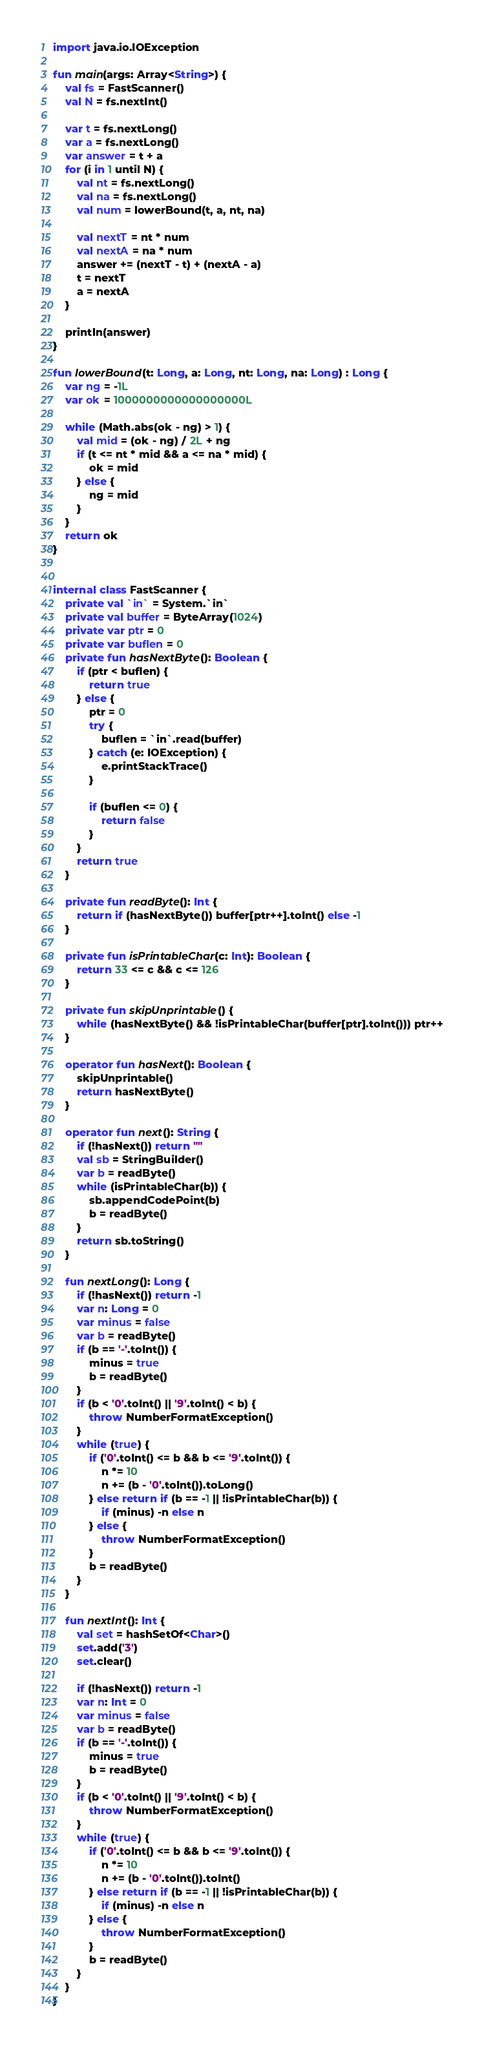Convert code to text. <code><loc_0><loc_0><loc_500><loc_500><_Kotlin_>import java.io.IOException

fun main(args: Array<String>) {
    val fs = FastScanner()
    val N = fs.nextInt()

    var t = fs.nextLong()
    var a = fs.nextLong()
    var answer = t + a
    for (i in 1 until N) {
        val nt = fs.nextLong()
        val na = fs.nextLong()
        val num = lowerBound(t, a, nt, na)

        val nextT = nt * num
        val nextA = na * num
        answer += (nextT - t) + (nextA - a)
        t = nextT
        a = nextA
    }

    println(answer)
}

fun lowerBound(t: Long, a: Long, nt: Long, na: Long) : Long {
    var ng = -1L
    var ok = 1000000000000000000L

    while (Math.abs(ok - ng) > 1) {
        val mid = (ok - ng) / 2L + ng
        if (t <= nt * mid && a <= na * mid) {
            ok = mid
        } else {
            ng = mid
        }
    }
    return ok
}


internal class FastScanner {
    private val `in` = System.`in`
    private val buffer = ByteArray(1024)
    private var ptr = 0
    private var buflen = 0
    private fun hasNextByte(): Boolean {
        if (ptr < buflen) {
            return true
        } else {
            ptr = 0
            try {
                buflen = `in`.read(buffer)
            } catch (e: IOException) {
                e.printStackTrace()
            }

            if (buflen <= 0) {
                return false
            }
        }
        return true
    }

    private fun readByte(): Int {
        return if (hasNextByte()) buffer[ptr++].toInt() else -1
    }

    private fun isPrintableChar(c: Int): Boolean {
        return 33 <= c && c <= 126
    }

    private fun skipUnprintable() {
        while (hasNextByte() && !isPrintableChar(buffer[ptr].toInt())) ptr++
    }

    operator fun hasNext(): Boolean {
        skipUnprintable()
        return hasNextByte()
    }

    operator fun next(): String {
        if (!hasNext()) return ""
        val sb = StringBuilder()
        var b = readByte()
        while (isPrintableChar(b)) {
            sb.appendCodePoint(b)
            b = readByte()
        }
        return sb.toString()
    }

    fun nextLong(): Long {
        if (!hasNext()) return -1
        var n: Long = 0
        var minus = false
        var b = readByte()
        if (b == '-'.toInt()) {
            minus = true
            b = readByte()
        }
        if (b < '0'.toInt() || '9'.toInt() < b) {
            throw NumberFormatException()
        }
        while (true) {
            if ('0'.toInt() <= b && b <= '9'.toInt()) {
                n *= 10
                n += (b - '0'.toInt()).toLong()
            } else return if (b == -1 || !isPrintableChar(b)) {
                if (minus) -n else n
            } else {
                throw NumberFormatException()
            }
            b = readByte()
        }
    }

    fun nextInt(): Int {
        val set = hashSetOf<Char>()
        set.add('3')
        set.clear()

        if (!hasNext()) return -1
        var n: Int = 0
        var minus = false
        var b = readByte()
        if (b == '-'.toInt()) {
            minus = true
            b = readByte()
        }
        if (b < '0'.toInt() || '9'.toInt() < b) {
            throw NumberFormatException()
        }
        while (true) {
            if ('0'.toInt() <= b && b <= '9'.toInt()) {
                n *= 10
                n += (b - '0'.toInt()).toInt()
            } else return if (b == -1 || !isPrintableChar(b)) {
                if (minus) -n else n
            } else {
                throw NumberFormatException()
            }
            b = readByte()
        }
    }
}</code> 